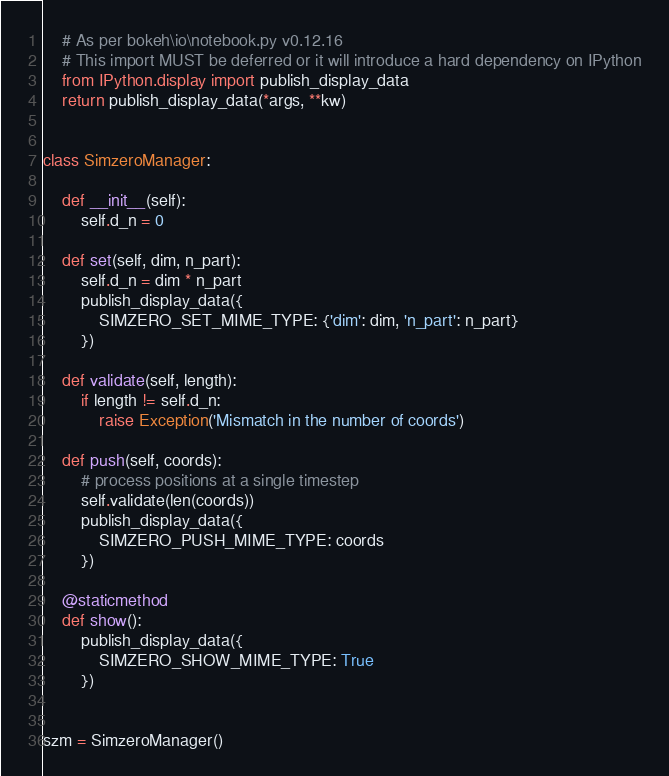Convert code to text. <code><loc_0><loc_0><loc_500><loc_500><_Python_>    # As per bokeh\io\notebook.py v0.12.16
    # This import MUST be deferred or it will introduce a hard dependency on IPython
    from IPython.display import publish_display_data
    return publish_display_data(*args, **kw)


class SimzeroManager:

    def __init__(self):
        self.d_n = 0

    def set(self, dim, n_part):
        self.d_n = dim * n_part
        publish_display_data({
            SIMZERO_SET_MIME_TYPE: {'dim': dim, 'n_part': n_part}
        })

    def validate(self, length):
        if length != self.d_n:
            raise Exception('Mismatch in the number of coords')

    def push(self, coords):
        # process positions at a single timestep
        self.validate(len(coords))
        publish_display_data({
            SIMZERO_PUSH_MIME_TYPE: coords
        })

    @staticmethod
    def show():
        publish_display_data({
            SIMZERO_SHOW_MIME_TYPE: True
        })


szm = SimzeroManager()
</code> 